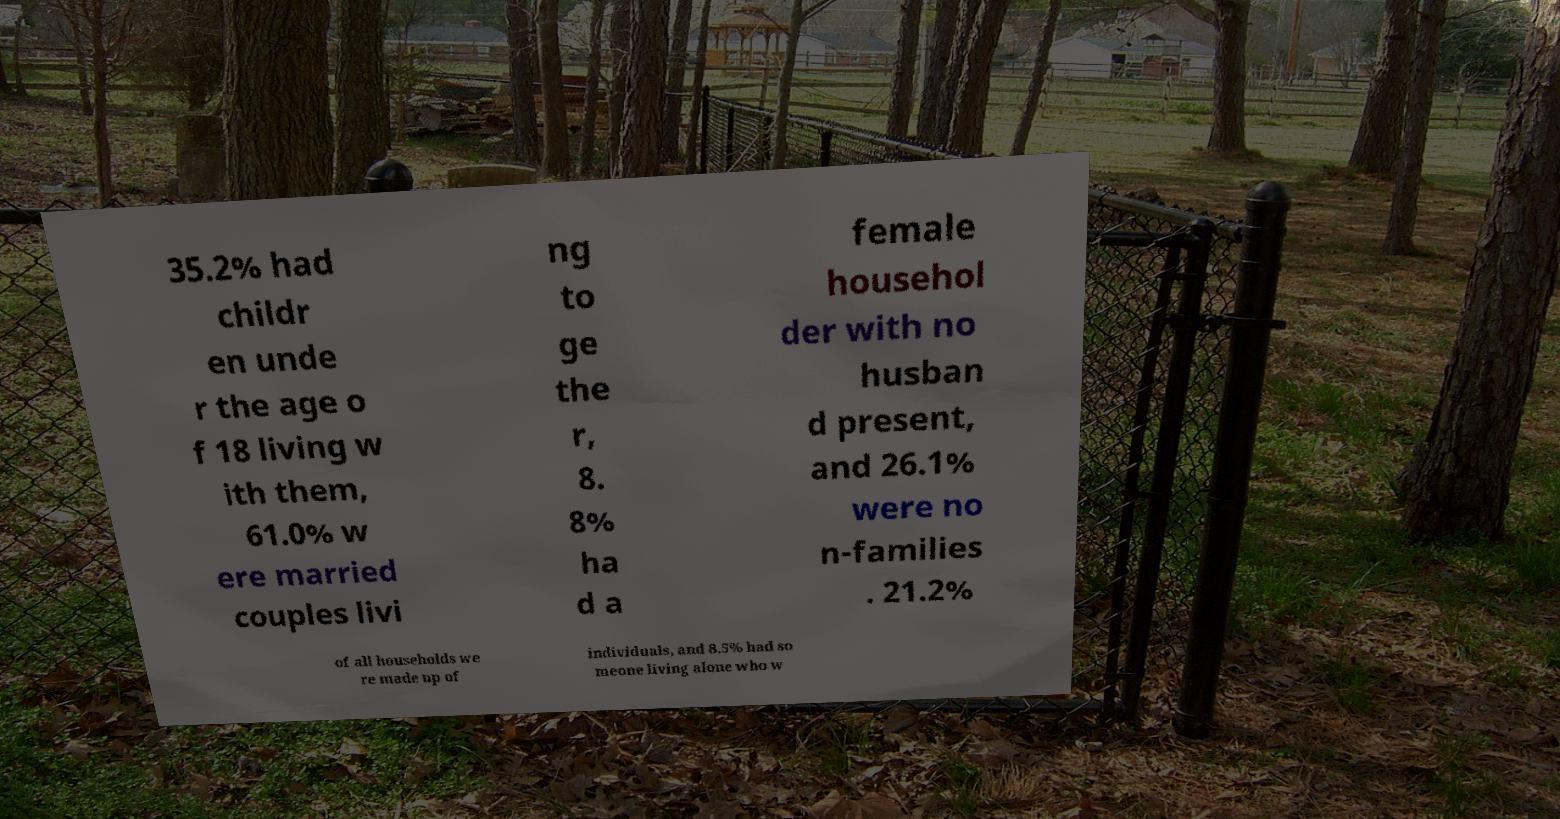What messages or text are displayed in this image? I need them in a readable, typed format. 35.2% had childr en unde r the age o f 18 living w ith them, 61.0% w ere married couples livi ng to ge the r, 8. 8% ha d a female househol der with no husban d present, and 26.1% were no n-families . 21.2% of all households we re made up of individuals, and 8.5% had so meone living alone who w 